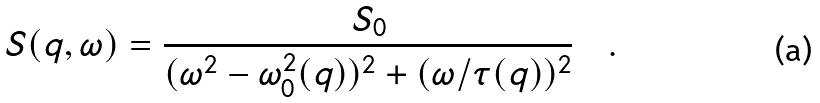<formula> <loc_0><loc_0><loc_500><loc_500>S ( q , \omega ) = \frac { S _ { 0 } } { ( \omega ^ { 2 } - \omega ^ { 2 } _ { 0 } ( q ) ) ^ { 2 } + ( { \omega } / { \tau ( q ) } ) ^ { 2 } } \quad .</formula> 